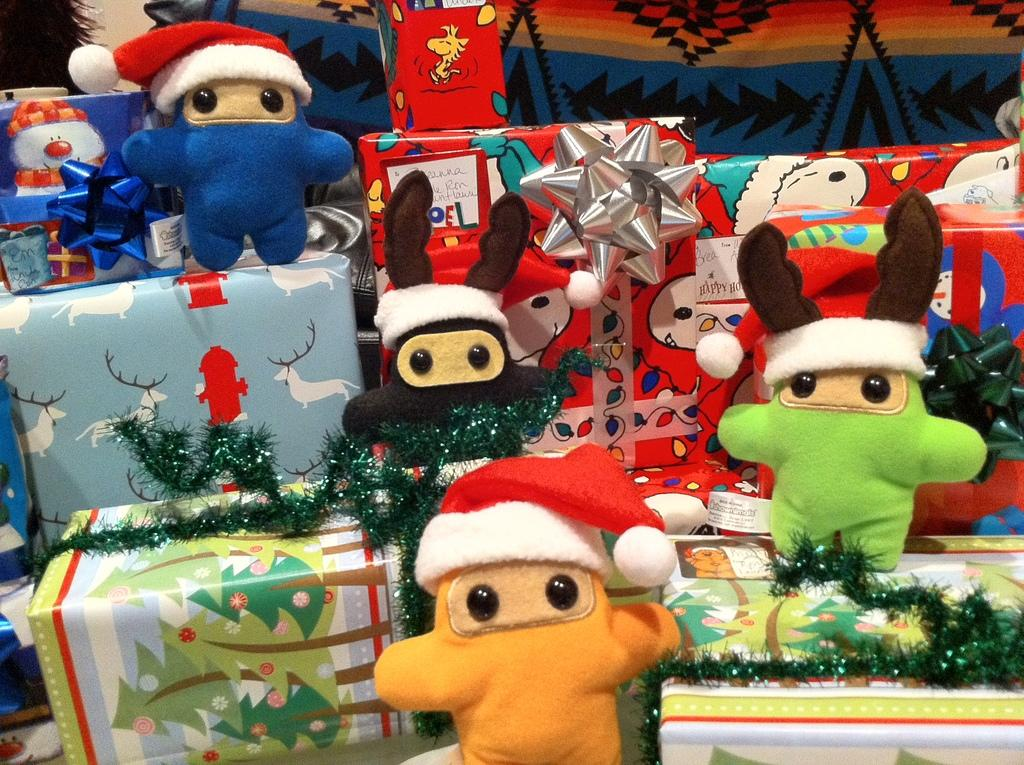What is placed on top of the gift boxes in the image? There are dolls on the gift boxes in the image. What other items can be seen in the image besides the dolls? There are decorative items in the image. Can you describe the background of the image? There is a cloth visible in the background of the image. What type of patch can be seen on the bear in the image? There is no bear present in the image; it features dolls on gift boxes and decorative items. 